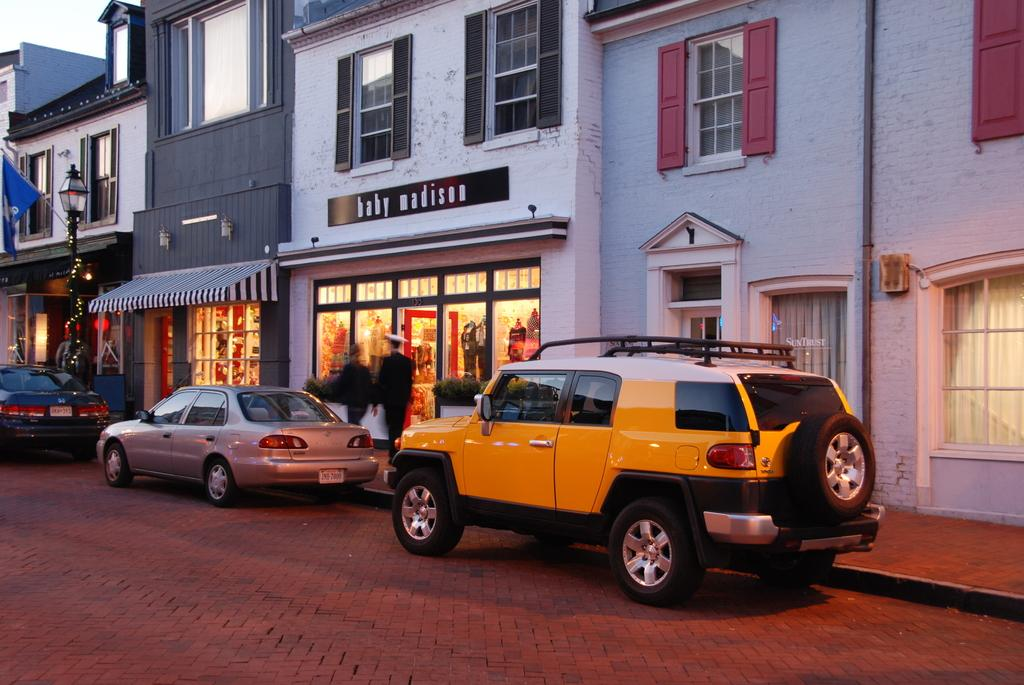What type of structures can be seen in the image? There are buildings in the image. What can be found on the buildings in the image? There are name boards on the buildings in the image. What type of establishments are present in the image? There are stores in the image. What mode of transportation can be seen on the road? Motor vehicles are visible on the road. What type of vegetation is present in the image? Houseplants are present in the image. What type of vertical structure is present in the image? There is a street pole in the image. What type of lighting fixture is present in the image? There is a street light in the image. What are the people in the image doing? Persons are walking on the footpath. What part of the natural environment is visible in the image? The sky is visible in the image. What type of punishment is being handed out by the street light in the image? There is no punishment being handed out by the street light in the image; it is a lighting fixture. What type of debt is being discussed by the houseplants in the image? There is no discussion of debt by the houseplants in the image; they are plants. 